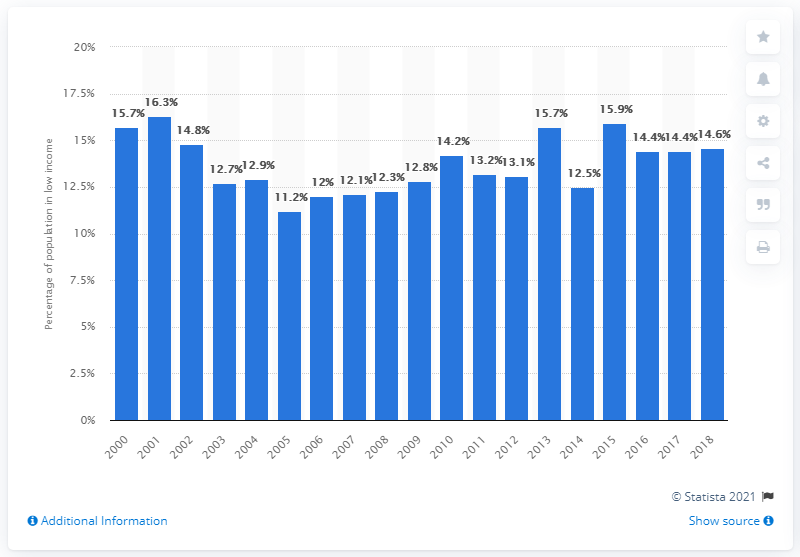Draw attention to some important aspects in this diagram. In 2018, approximately 14.6% of the population of Prince Edward Island was considered to be living in low income, according to statistics released by the government. 